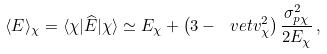Convert formula to latex. <formula><loc_0><loc_0><loc_500><loc_500>\langle E \rangle _ { \chi } = \langle \chi | \widehat { E } | \chi \rangle \simeq E _ { \chi } + \left ( 3 - \ v e t { v } _ { \chi } ^ { 2 } \right ) \frac { \sigma _ { p \chi } ^ { 2 } } { 2 E _ { \chi } } \, ,</formula> 